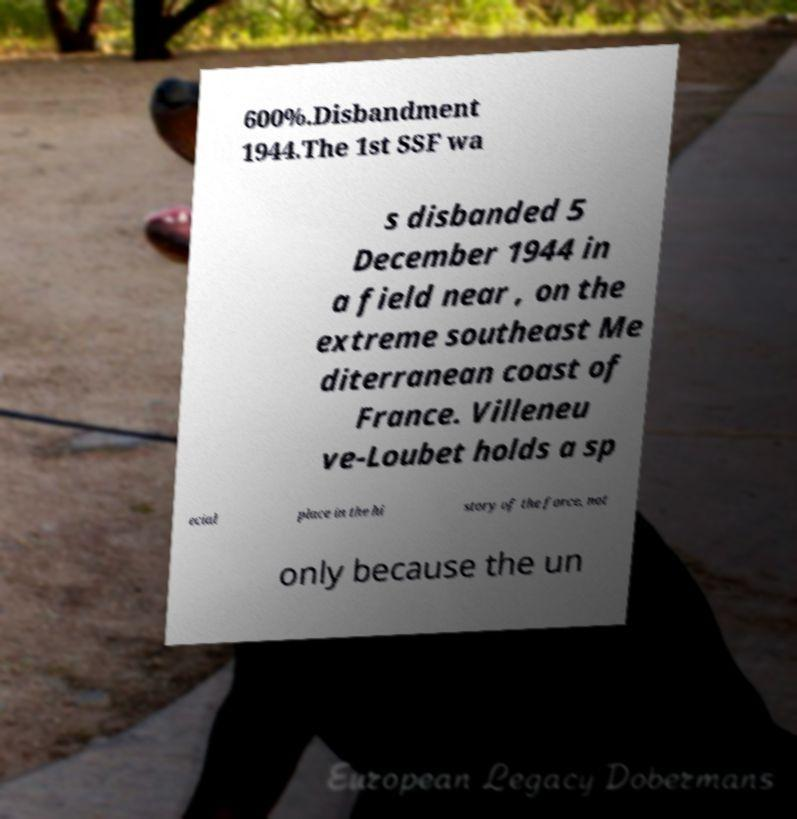For documentation purposes, I need the text within this image transcribed. Could you provide that? 600%.Disbandment 1944.The 1st SSF wa s disbanded 5 December 1944 in a field near , on the extreme southeast Me diterranean coast of France. Villeneu ve-Loubet holds a sp ecial place in the hi story of the force, not only because the un 